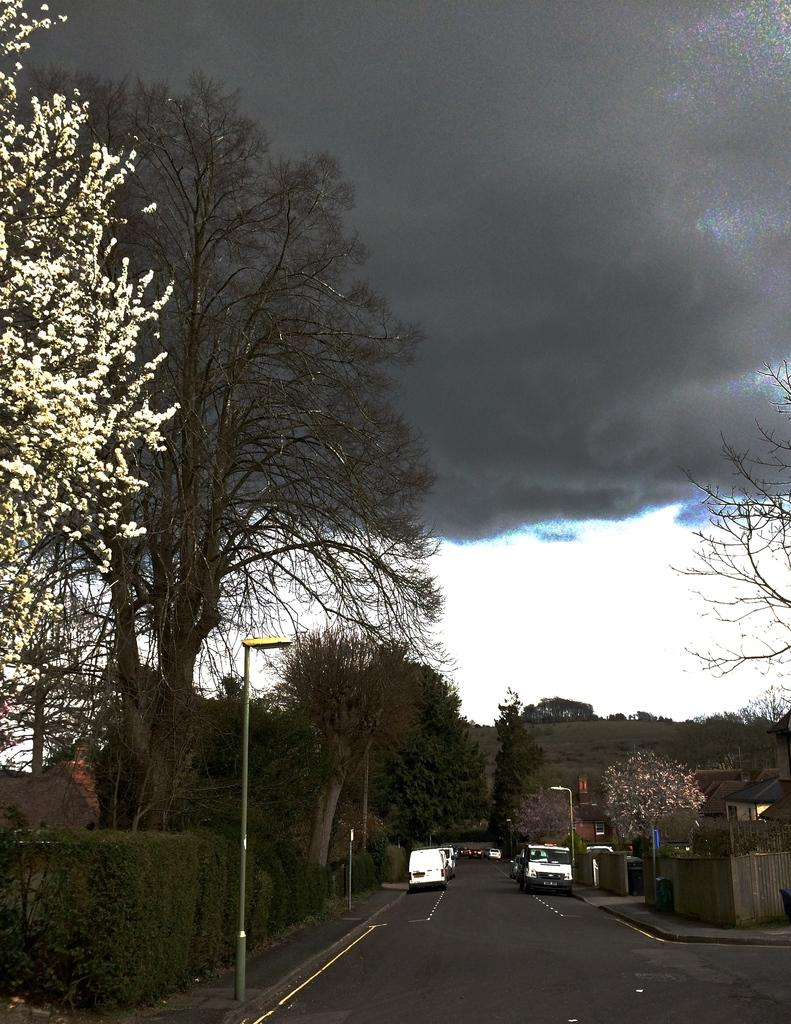What is happening on the road in the image? Vehicles are moving on the road in the image. What can be seen beside the road? There are trees and plants beside the road. How would you describe the sky in the image? The sky is clouded in the image. Can you see any waves in the image? There are no waves present in the image, as it features a road with vehicles and surrounding vegetation. 